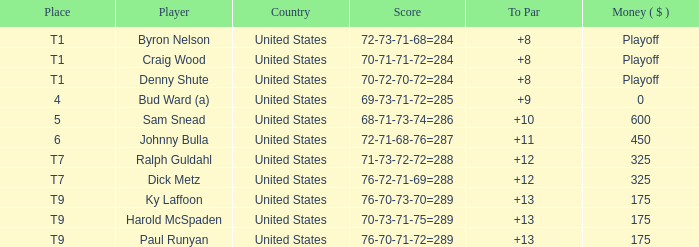What was the score for t9 place for Harold Mcspaden? 70-73-71-75=289. 